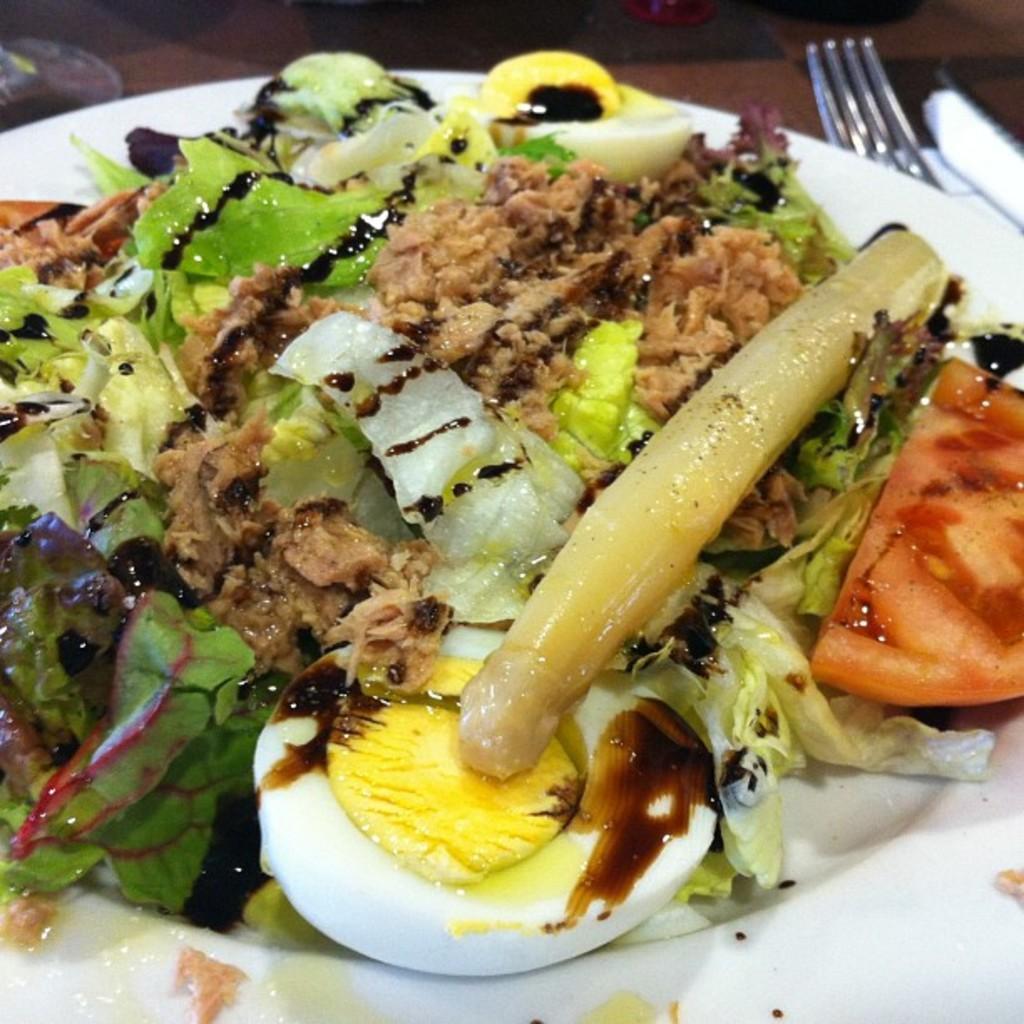In one or two sentences, can you explain what this image depicts? In this image we can see some food on the white plate, one fork, one knife and some objects on the table. 